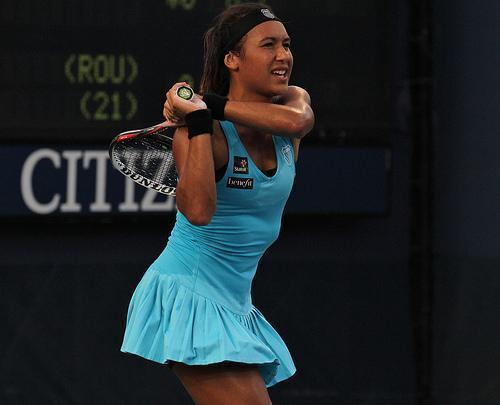How many tennis players are shown?
Give a very brief answer. 1. 